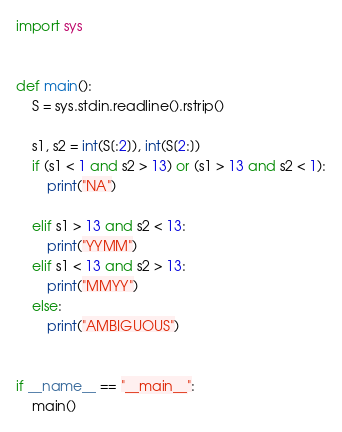Convert code to text. <code><loc_0><loc_0><loc_500><loc_500><_Python_>import sys


def main():
    S = sys.stdin.readline().rstrip()

    s1, s2 = int(S[:2]), int(S[2:])
    if (s1 < 1 and s2 > 13) or (s1 > 13 and s2 < 1):
        print("NA")

    elif s1 > 13 and s2 < 13:
        print("YYMM")
    elif s1 < 13 and s2 > 13:
        print("MMYY")
    else:
        print("AMBIGUOUS")


if __name__ == "__main__":
    main()</code> 